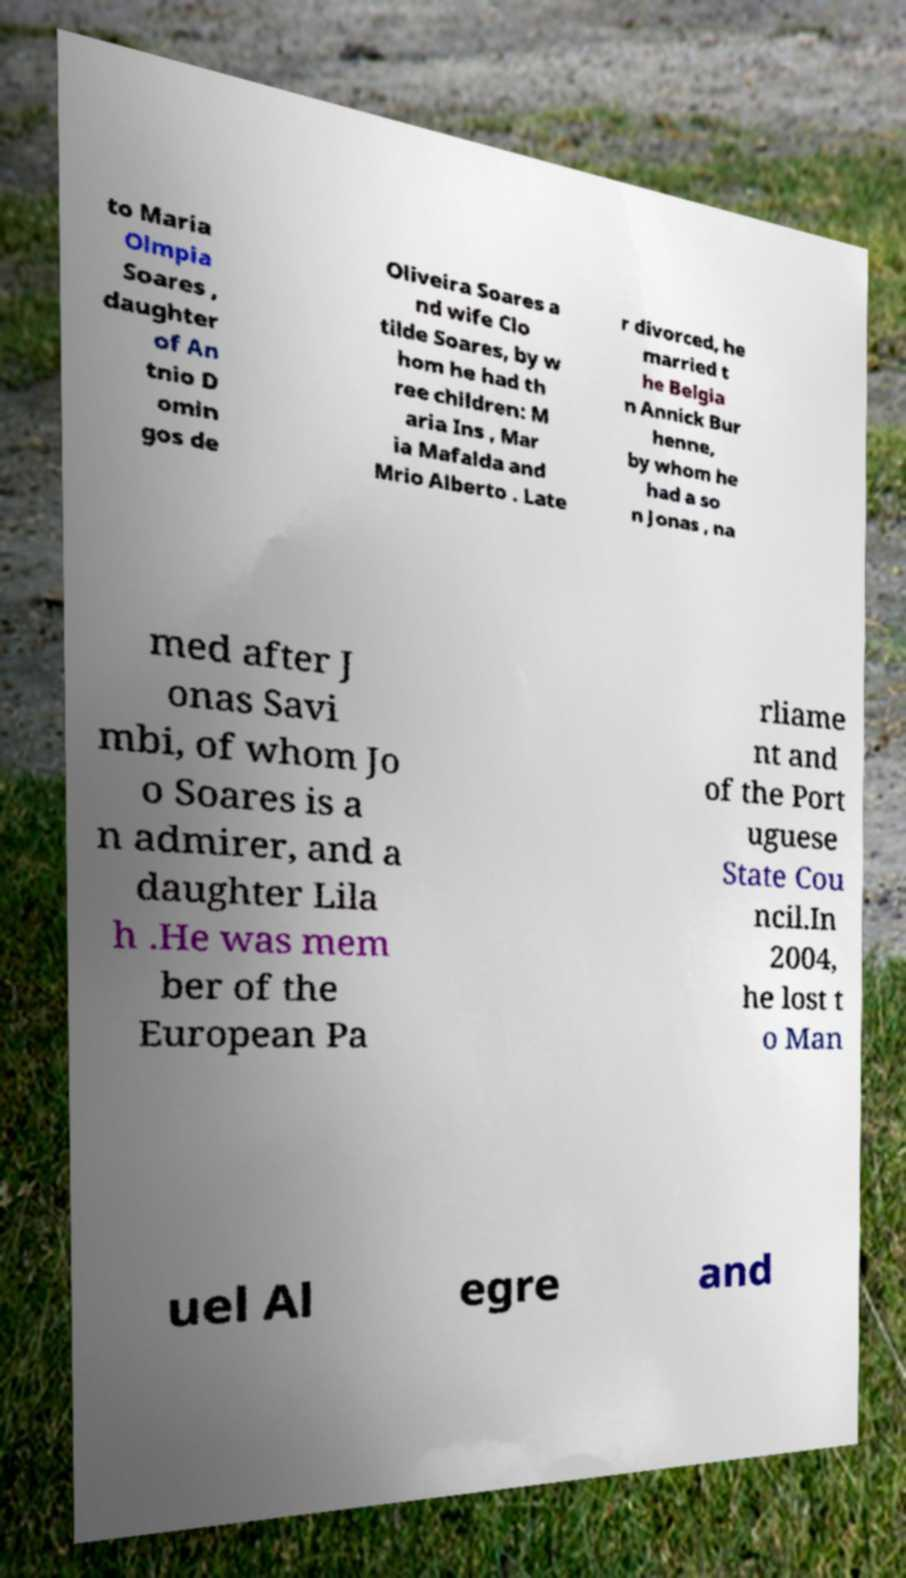I need the written content from this picture converted into text. Can you do that? to Maria Olmpia Soares , daughter of An tnio D omin gos de Oliveira Soares a nd wife Clo tilde Soares, by w hom he had th ree children: M aria Ins , Mar ia Mafalda and Mrio Alberto . Late r divorced, he married t he Belgia n Annick Bur henne, by whom he had a so n Jonas , na med after J onas Savi mbi, of whom Jo o Soares is a n admirer, and a daughter Lila h .He was mem ber of the European Pa rliame nt and of the Port uguese State Cou ncil.In 2004, he lost t o Man uel Al egre and 